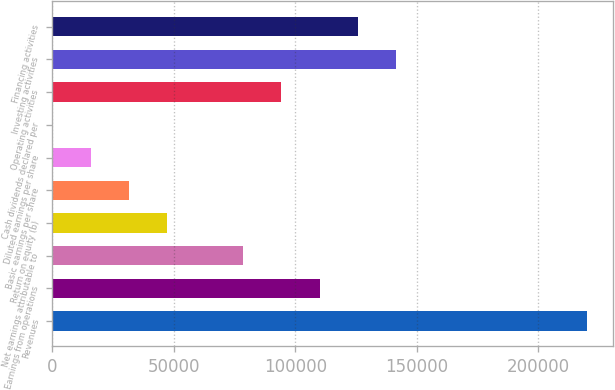<chart> <loc_0><loc_0><loc_500><loc_500><bar_chart><fcel>Revenues<fcel>Earnings from operations<fcel>Net earnings attributable to<fcel>Return on equity (b)<fcel>Basic earnings per share<fcel>Diluted earnings per share<fcel>Cash dividends declared per<fcel>Operating activities<fcel>Investing activities<fcel>Financing activities<nl><fcel>219949<fcel>109975<fcel>78554.4<fcel>47133.4<fcel>31422.9<fcel>15712.4<fcel>1.88<fcel>94264.9<fcel>141396<fcel>125686<nl></chart> 